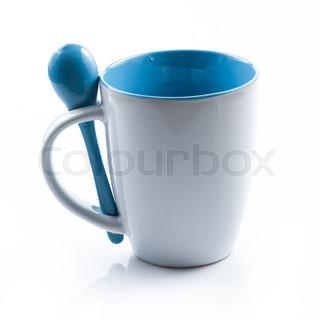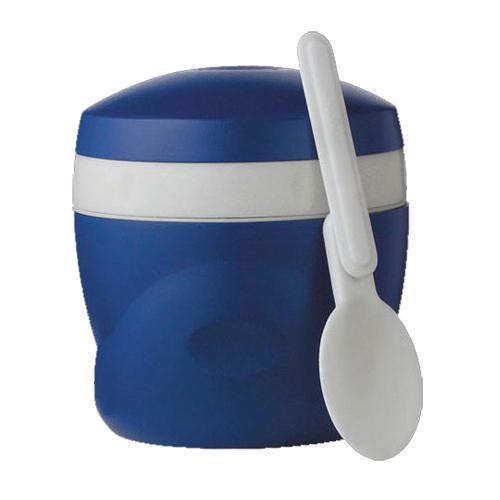The first image is the image on the left, the second image is the image on the right. Given the left and right images, does the statement "An image includes a royal blue container with a white stripe and white spoon." hold true? Answer yes or no. Yes. 